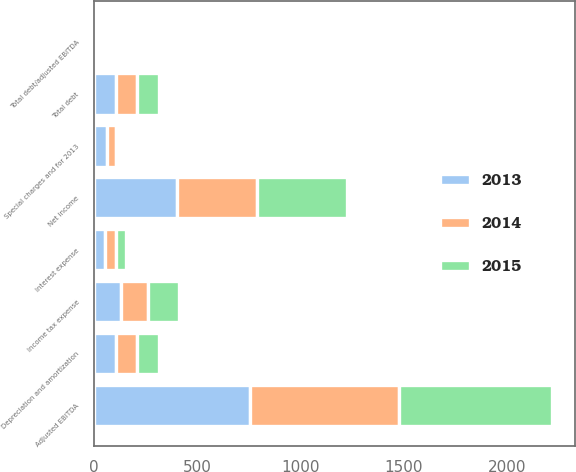Convert chart. <chart><loc_0><loc_0><loc_500><loc_500><stacked_bar_chart><ecel><fcel>Net income<fcel>Special charges and for 2013<fcel>Depreciation and amortization<fcel>Interest expense<fcel>Income tax expense<fcel>Adjusted EBITDA<fcel>Total debt<fcel>Total debt/adjusted EBITDA<nl><fcel>2013<fcel>401.6<fcel>65.5<fcel>105.9<fcel>53.3<fcel>131.3<fcel>755.6<fcel>105.9<fcel>1.85<nl><fcel>2015<fcel>437.9<fcel>5.2<fcel>102.7<fcel>49.7<fcel>145.9<fcel>741.4<fcel>105.9<fcel>1.73<nl><fcel>2014<fcel>389<fcel>40.3<fcel>106<fcel>53.3<fcel>133.6<fcel>722.2<fcel>105.9<fcel>1.71<nl></chart> 